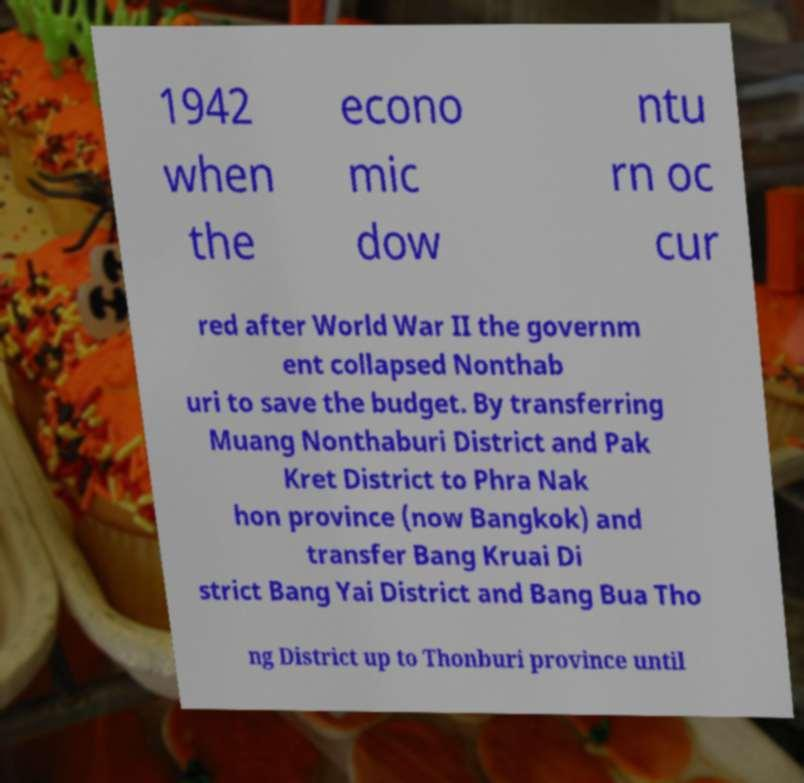What messages or text are displayed in this image? I need them in a readable, typed format. 1942 when the econo mic dow ntu rn oc cur red after World War II the governm ent collapsed Nonthab uri to save the budget. By transferring Muang Nonthaburi District and Pak Kret District to Phra Nak hon province (now Bangkok) and transfer Bang Kruai Di strict Bang Yai District and Bang Bua Tho ng District up to Thonburi province until 